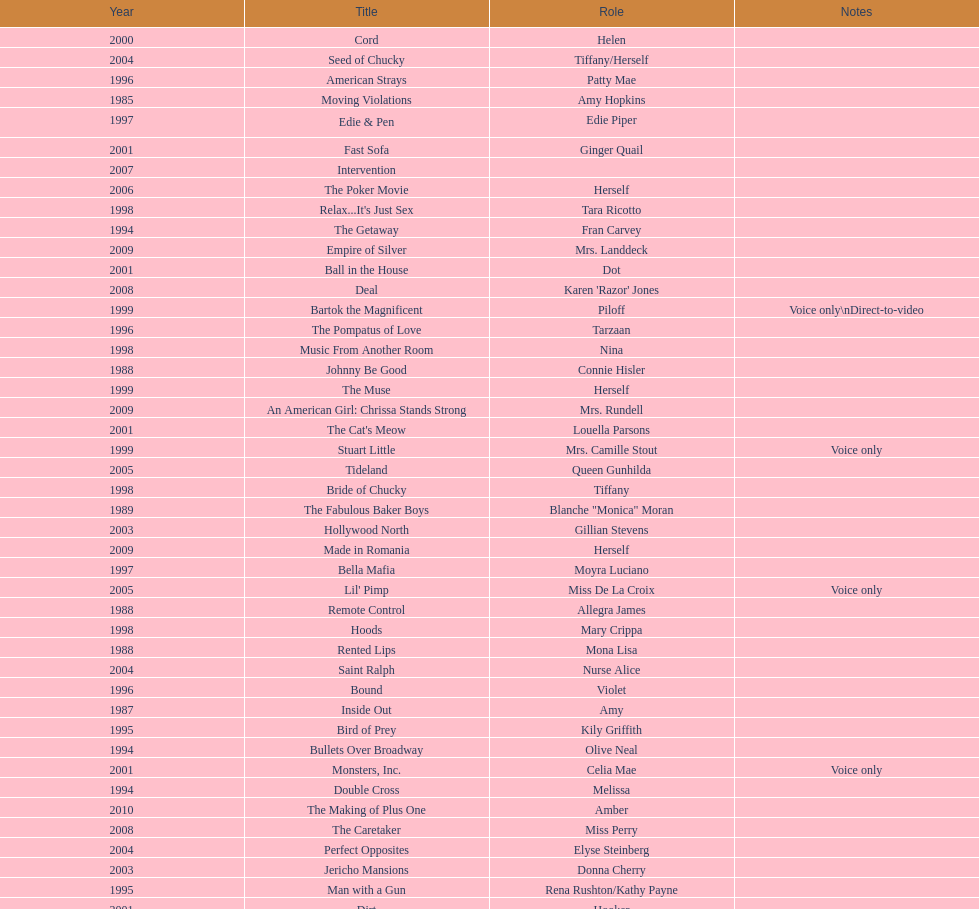Which film has their role under igiyook? Shadow of the Wolf. 